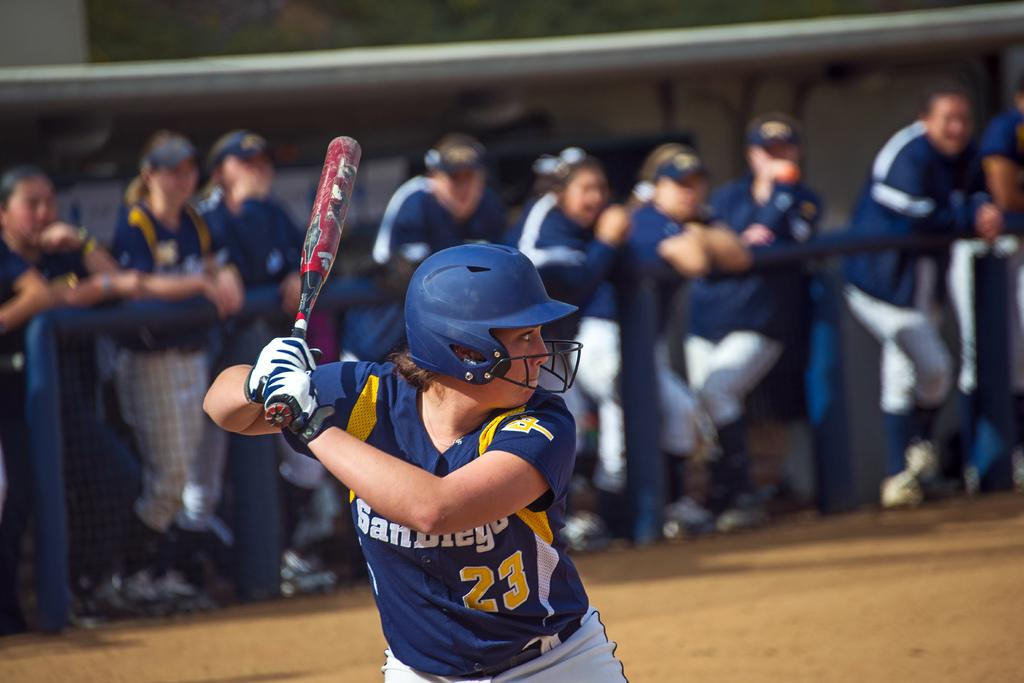<image>
Offer a succinct explanation of the picture presented. a boy in San Diego jersey number 23 up to bat 